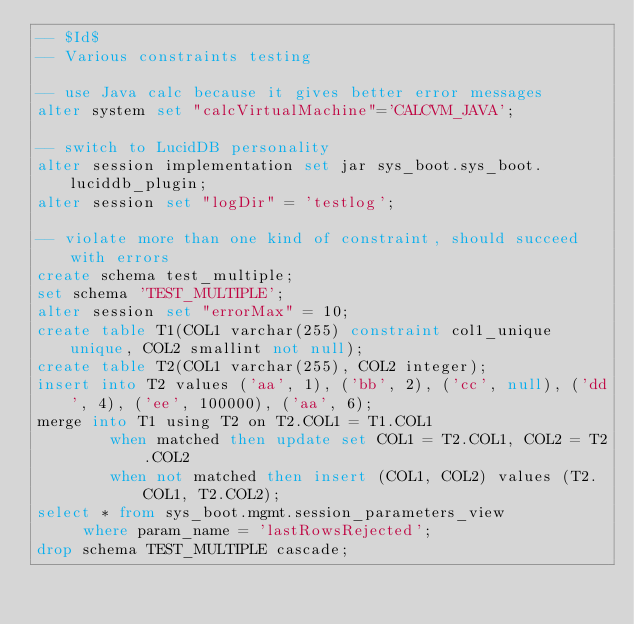Convert code to text. <code><loc_0><loc_0><loc_500><loc_500><_SQL_>-- $Id$
-- Various constraints testing

-- use Java calc because it gives better error messages
alter system set "calcVirtualMachine"='CALCVM_JAVA';

-- switch to LucidDB personality
alter session implementation set jar sys_boot.sys_boot.luciddb_plugin;
alter session set "logDir" = 'testlog';

-- violate more than one kind of constraint, should succeed with errors
create schema test_multiple;
set schema 'TEST_MULTIPLE';
alter session set "errorMax" = 10;
create table T1(COL1 varchar(255) constraint col1_unique unique, COL2 smallint not null);
create table T2(COL1 varchar(255), COL2 integer);
insert into T2 values ('aa', 1), ('bb', 2), ('cc', null), ('dd', 4), ('ee', 100000), ('aa', 6);
merge into T1 using T2 on T2.COL1 = T1.COL1 
        when matched then update set COL1 = T2.COL1, COL2 = T2.COL2 
        when not matched then insert (COL1, COL2) values (T2.COL1, T2.COL2);
select * from sys_boot.mgmt.session_parameters_view
     where param_name = 'lastRowsRejected';
drop schema TEST_MULTIPLE cascade;
</code> 